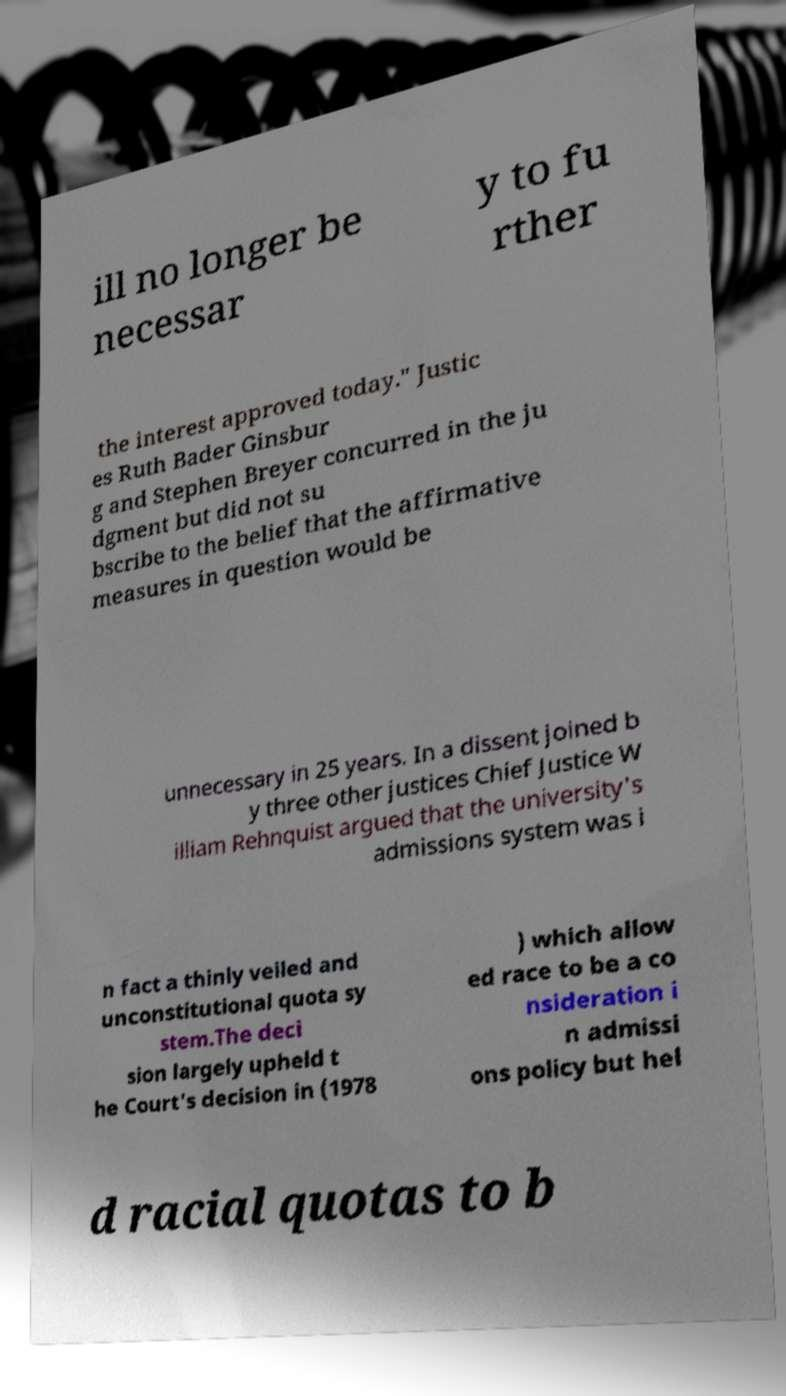Could you extract and type out the text from this image? ill no longer be necessar y to fu rther the interest approved today." Justic es Ruth Bader Ginsbur g and Stephen Breyer concurred in the ju dgment but did not su bscribe to the belief that the affirmative measures in question would be unnecessary in 25 years. In a dissent joined b y three other justices Chief Justice W illiam Rehnquist argued that the university's admissions system was i n fact a thinly veiled and unconstitutional quota sy stem.The deci sion largely upheld t he Court's decision in (1978 ) which allow ed race to be a co nsideration i n admissi ons policy but hel d racial quotas to b 